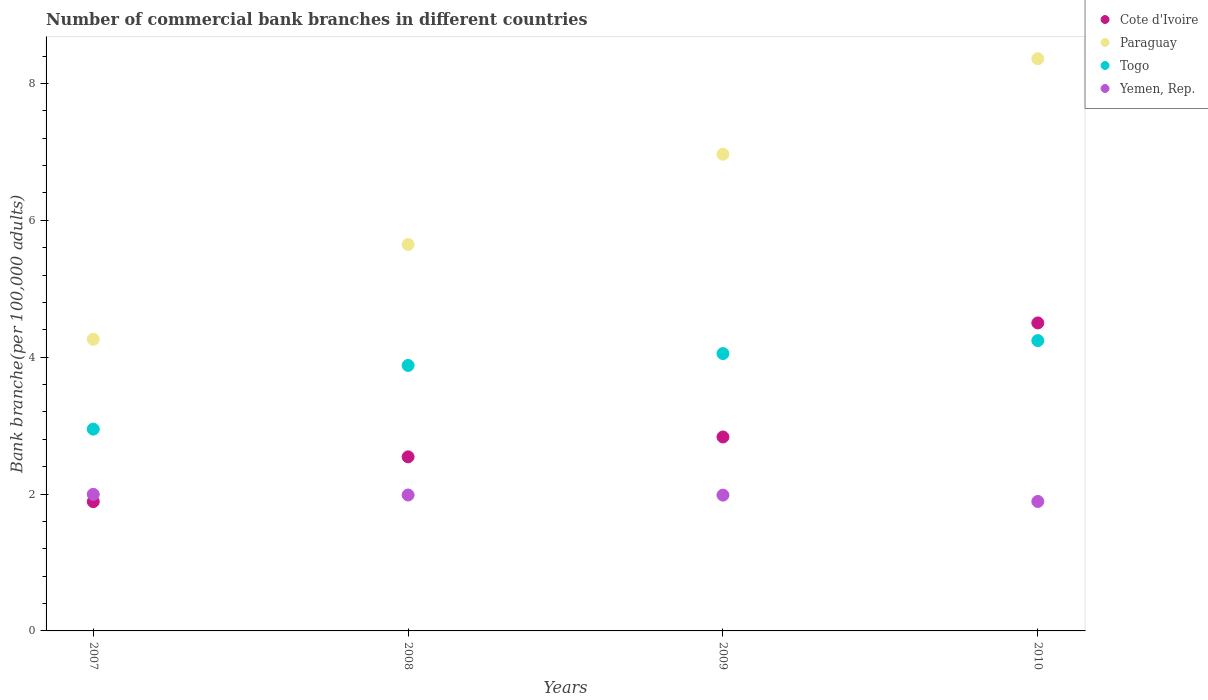Is the number of dotlines equal to the number of legend labels?
Make the answer very short. Yes. What is the number of commercial bank branches in Yemen, Rep. in 2008?
Keep it short and to the point. 1.99. Across all years, what is the maximum number of commercial bank branches in Cote d'Ivoire?
Your response must be concise. 4.5. Across all years, what is the minimum number of commercial bank branches in Cote d'Ivoire?
Provide a short and direct response. 1.89. In which year was the number of commercial bank branches in Cote d'Ivoire maximum?
Provide a succinct answer. 2010. In which year was the number of commercial bank branches in Togo minimum?
Make the answer very short. 2007. What is the total number of commercial bank branches in Paraguay in the graph?
Ensure brevity in your answer.  25.24. What is the difference between the number of commercial bank branches in Cote d'Ivoire in 2008 and that in 2010?
Give a very brief answer. -1.96. What is the difference between the number of commercial bank branches in Togo in 2008 and the number of commercial bank branches in Paraguay in 2010?
Make the answer very short. -4.48. What is the average number of commercial bank branches in Togo per year?
Provide a succinct answer. 3.78. In the year 2010, what is the difference between the number of commercial bank branches in Paraguay and number of commercial bank branches in Cote d'Ivoire?
Provide a short and direct response. 3.86. In how many years, is the number of commercial bank branches in Yemen, Rep. greater than 2?
Your answer should be very brief. 0. What is the ratio of the number of commercial bank branches in Togo in 2007 to that in 2008?
Make the answer very short. 0.76. Is the number of commercial bank branches in Cote d'Ivoire in 2009 less than that in 2010?
Provide a short and direct response. Yes. Is the difference between the number of commercial bank branches in Paraguay in 2008 and 2010 greater than the difference between the number of commercial bank branches in Cote d'Ivoire in 2008 and 2010?
Ensure brevity in your answer.  No. What is the difference between the highest and the second highest number of commercial bank branches in Togo?
Your answer should be compact. 0.19. What is the difference between the highest and the lowest number of commercial bank branches in Cote d'Ivoire?
Offer a very short reply. 2.61. In how many years, is the number of commercial bank branches in Cote d'Ivoire greater than the average number of commercial bank branches in Cote d'Ivoire taken over all years?
Keep it short and to the point. 1. Is the sum of the number of commercial bank branches in Togo in 2007 and 2010 greater than the maximum number of commercial bank branches in Paraguay across all years?
Provide a short and direct response. No. Is it the case that in every year, the sum of the number of commercial bank branches in Cote d'Ivoire and number of commercial bank branches in Yemen, Rep.  is greater than the sum of number of commercial bank branches in Paraguay and number of commercial bank branches in Togo?
Offer a terse response. No. Is the number of commercial bank branches in Paraguay strictly less than the number of commercial bank branches in Cote d'Ivoire over the years?
Your answer should be compact. No. How many dotlines are there?
Keep it short and to the point. 4. How many years are there in the graph?
Provide a succinct answer. 4. What is the difference between two consecutive major ticks on the Y-axis?
Your response must be concise. 2. Does the graph contain any zero values?
Make the answer very short. No. Where does the legend appear in the graph?
Offer a terse response. Top right. How many legend labels are there?
Offer a very short reply. 4. What is the title of the graph?
Offer a very short reply. Number of commercial bank branches in different countries. Does "Latin America(developing only)" appear as one of the legend labels in the graph?
Keep it short and to the point. No. What is the label or title of the X-axis?
Give a very brief answer. Years. What is the label or title of the Y-axis?
Your answer should be very brief. Bank branche(per 100,0 adults). What is the Bank branche(per 100,000 adults) of Cote d'Ivoire in 2007?
Offer a terse response. 1.89. What is the Bank branche(per 100,000 adults) of Paraguay in 2007?
Provide a succinct answer. 4.26. What is the Bank branche(per 100,000 adults) of Togo in 2007?
Your answer should be compact. 2.95. What is the Bank branche(per 100,000 adults) in Yemen, Rep. in 2007?
Provide a succinct answer. 2. What is the Bank branche(per 100,000 adults) of Cote d'Ivoire in 2008?
Offer a terse response. 2.54. What is the Bank branche(per 100,000 adults) in Paraguay in 2008?
Provide a short and direct response. 5.65. What is the Bank branche(per 100,000 adults) in Togo in 2008?
Your response must be concise. 3.88. What is the Bank branche(per 100,000 adults) in Yemen, Rep. in 2008?
Your answer should be compact. 1.99. What is the Bank branche(per 100,000 adults) in Cote d'Ivoire in 2009?
Give a very brief answer. 2.83. What is the Bank branche(per 100,000 adults) of Paraguay in 2009?
Your answer should be compact. 6.97. What is the Bank branche(per 100,000 adults) in Togo in 2009?
Give a very brief answer. 4.05. What is the Bank branche(per 100,000 adults) of Yemen, Rep. in 2009?
Your answer should be compact. 1.98. What is the Bank branche(per 100,000 adults) in Cote d'Ivoire in 2010?
Provide a short and direct response. 4.5. What is the Bank branche(per 100,000 adults) of Paraguay in 2010?
Provide a short and direct response. 8.36. What is the Bank branche(per 100,000 adults) of Togo in 2010?
Offer a very short reply. 4.24. What is the Bank branche(per 100,000 adults) in Yemen, Rep. in 2010?
Give a very brief answer. 1.89. Across all years, what is the maximum Bank branche(per 100,000 adults) of Cote d'Ivoire?
Your answer should be very brief. 4.5. Across all years, what is the maximum Bank branche(per 100,000 adults) in Paraguay?
Your answer should be compact. 8.36. Across all years, what is the maximum Bank branche(per 100,000 adults) of Togo?
Offer a very short reply. 4.24. Across all years, what is the maximum Bank branche(per 100,000 adults) in Yemen, Rep.?
Offer a terse response. 2. Across all years, what is the minimum Bank branche(per 100,000 adults) in Cote d'Ivoire?
Your response must be concise. 1.89. Across all years, what is the minimum Bank branche(per 100,000 adults) in Paraguay?
Give a very brief answer. 4.26. Across all years, what is the minimum Bank branche(per 100,000 adults) in Togo?
Provide a short and direct response. 2.95. Across all years, what is the minimum Bank branche(per 100,000 adults) in Yemen, Rep.?
Give a very brief answer. 1.89. What is the total Bank branche(per 100,000 adults) of Cote d'Ivoire in the graph?
Give a very brief answer. 11.77. What is the total Bank branche(per 100,000 adults) of Paraguay in the graph?
Your response must be concise. 25.24. What is the total Bank branche(per 100,000 adults) in Togo in the graph?
Offer a very short reply. 15.13. What is the total Bank branche(per 100,000 adults) in Yemen, Rep. in the graph?
Give a very brief answer. 7.86. What is the difference between the Bank branche(per 100,000 adults) of Cote d'Ivoire in 2007 and that in 2008?
Keep it short and to the point. -0.65. What is the difference between the Bank branche(per 100,000 adults) in Paraguay in 2007 and that in 2008?
Provide a short and direct response. -1.39. What is the difference between the Bank branche(per 100,000 adults) in Togo in 2007 and that in 2008?
Offer a very short reply. -0.93. What is the difference between the Bank branche(per 100,000 adults) in Yemen, Rep. in 2007 and that in 2008?
Your answer should be compact. 0.01. What is the difference between the Bank branche(per 100,000 adults) in Cote d'Ivoire in 2007 and that in 2009?
Your answer should be very brief. -0.94. What is the difference between the Bank branche(per 100,000 adults) of Paraguay in 2007 and that in 2009?
Keep it short and to the point. -2.7. What is the difference between the Bank branche(per 100,000 adults) in Togo in 2007 and that in 2009?
Provide a succinct answer. -1.1. What is the difference between the Bank branche(per 100,000 adults) of Yemen, Rep. in 2007 and that in 2009?
Provide a succinct answer. 0.01. What is the difference between the Bank branche(per 100,000 adults) in Cote d'Ivoire in 2007 and that in 2010?
Offer a very short reply. -2.61. What is the difference between the Bank branche(per 100,000 adults) of Paraguay in 2007 and that in 2010?
Make the answer very short. -4.1. What is the difference between the Bank branche(per 100,000 adults) of Togo in 2007 and that in 2010?
Keep it short and to the point. -1.29. What is the difference between the Bank branche(per 100,000 adults) of Yemen, Rep. in 2007 and that in 2010?
Your answer should be very brief. 0.1. What is the difference between the Bank branche(per 100,000 adults) in Cote d'Ivoire in 2008 and that in 2009?
Your answer should be very brief. -0.29. What is the difference between the Bank branche(per 100,000 adults) of Paraguay in 2008 and that in 2009?
Your answer should be very brief. -1.32. What is the difference between the Bank branche(per 100,000 adults) in Togo in 2008 and that in 2009?
Provide a short and direct response. -0.17. What is the difference between the Bank branche(per 100,000 adults) in Yemen, Rep. in 2008 and that in 2009?
Give a very brief answer. 0. What is the difference between the Bank branche(per 100,000 adults) in Cote d'Ivoire in 2008 and that in 2010?
Your answer should be compact. -1.96. What is the difference between the Bank branche(per 100,000 adults) in Paraguay in 2008 and that in 2010?
Your answer should be very brief. -2.71. What is the difference between the Bank branche(per 100,000 adults) of Togo in 2008 and that in 2010?
Offer a very short reply. -0.36. What is the difference between the Bank branche(per 100,000 adults) in Yemen, Rep. in 2008 and that in 2010?
Give a very brief answer. 0.09. What is the difference between the Bank branche(per 100,000 adults) of Cote d'Ivoire in 2009 and that in 2010?
Offer a very short reply. -1.67. What is the difference between the Bank branche(per 100,000 adults) of Paraguay in 2009 and that in 2010?
Provide a short and direct response. -1.4. What is the difference between the Bank branche(per 100,000 adults) of Togo in 2009 and that in 2010?
Your answer should be compact. -0.19. What is the difference between the Bank branche(per 100,000 adults) in Yemen, Rep. in 2009 and that in 2010?
Your answer should be very brief. 0.09. What is the difference between the Bank branche(per 100,000 adults) of Cote d'Ivoire in 2007 and the Bank branche(per 100,000 adults) of Paraguay in 2008?
Offer a terse response. -3.76. What is the difference between the Bank branche(per 100,000 adults) of Cote d'Ivoire in 2007 and the Bank branche(per 100,000 adults) of Togo in 2008?
Ensure brevity in your answer.  -1.99. What is the difference between the Bank branche(per 100,000 adults) of Cote d'Ivoire in 2007 and the Bank branche(per 100,000 adults) of Yemen, Rep. in 2008?
Offer a terse response. -0.1. What is the difference between the Bank branche(per 100,000 adults) of Paraguay in 2007 and the Bank branche(per 100,000 adults) of Togo in 2008?
Provide a short and direct response. 0.38. What is the difference between the Bank branche(per 100,000 adults) of Paraguay in 2007 and the Bank branche(per 100,000 adults) of Yemen, Rep. in 2008?
Provide a short and direct response. 2.28. What is the difference between the Bank branche(per 100,000 adults) in Togo in 2007 and the Bank branche(per 100,000 adults) in Yemen, Rep. in 2008?
Your answer should be compact. 0.96. What is the difference between the Bank branche(per 100,000 adults) of Cote d'Ivoire in 2007 and the Bank branche(per 100,000 adults) of Paraguay in 2009?
Your response must be concise. -5.08. What is the difference between the Bank branche(per 100,000 adults) of Cote d'Ivoire in 2007 and the Bank branche(per 100,000 adults) of Togo in 2009?
Provide a short and direct response. -2.16. What is the difference between the Bank branche(per 100,000 adults) in Cote d'Ivoire in 2007 and the Bank branche(per 100,000 adults) in Yemen, Rep. in 2009?
Your answer should be compact. -0.1. What is the difference between the Bank branche(per 100,000 adults) in Paraguay in 2007 and the Bank branche(per 100,000 adults) in Togo in 2009?
Your answer should be compact. 0.21. What is the difference between the Bank branche(per 100,000 adults) of Paraguay in 2007 and the Bank branche(per 100,000 adults) of Yemen, Rep. in 2009?
Offer a very short reply. 2.28. What is the difference between the Bank branche(per 100,000 adults) of Togo in 2007 and the Bank branche(per 100,000 adults) of Yemen, Rep. in 2009?
Your answer should be compact. 0.96. What is the difference between the Bank branche(per 100,000 adults) of Cote d'Ivoire in 2007 and the Bank branche(per 100,000 adults) of Paraguay in 2010?
Give a very brief answer. -6.47. What is the difference between the Bank branche(per 100,000 adults) of Cote d'Ivoire in 2007 and the Bank branche(per 100,000 adults) of Togo in 2010?
Offer a very short reply. -2.35. What is the difference between the Bank branche(per 100,000 adults) of Cote d'Ivoire in 2007 and the Bank branche(per 100,000 adults) of Yemen, Rep. in 2010?
Offer a terse response. -0. What is the difference between the Bank branche(per 100,000 adults) in Paraguay in 2007 and the Bank branche(per 100,000 adults) in Togo in 2010?
Provide a succinct answer. 0.02. What is the difference between the Bank branche(per 100,000 adults) of Paraguay in 2007 and the Bank branche(per 100,000 adults) of Yemen, Rep. in 2010?
Provide a succinct answer. 2.37. What is the difference between the Bank branche(per 100,000 adults) in Togo in 2007 and the Bank branche(per 100,000 adults) in Yemen, Rep. in 2010?
Offer a very short reply. 1.06. What is the difference between the Bank branche(per 100,000 adults) of Cote d'Ivoire in 2008 and the Bank branche(per 100,000 adults) of Paraguay in 2009?
Provide a short and direct response. -4.42. What is the difference between the Bank branche(per 100,000 adults) of Cote d'Ivoire in 2008 and the Bank branche(per 100,000 adults) of Togo in 2009?
Make the answer very short. -1.51. What is the difference between the Bank branche(per 100,000 adults) in Cote d'Ivoire in 2008 and the Bank branche(per 100,000 adults) in Yemen, Rep. in 2009?
Offer a terse response. 0.56. What is the difference between the Bank branche(per 100,000 adults) in Paraguay in 2008 and the Bank branche(per 100,000 adults) in Togo in 2009?
Provide a succinct answer. 1.59. What is the difference between the Bank branche(per 100,000 adults) of Paraguay in 2008 and the Bank branche(per 100,000 adults) of Yemen, Rep. in 2009?
Your answer should be compact. 3.66. What is the difference between the Bank branche(per 100,000 adults) in Togo in 2008 and the Bank branche(per 100,000 adults) in Yemen, Rep. in 2009?
Your answer should be compact. 1.9. What is the difference between the Bank branche(per 100,000 adults) in Cote d'Ivoire in 2008 and the Bank branche(per 100,000 adults) in Paraguay in 2010?
Your answer should be compact. -5.82. What is the difference between the Bank branche(per 100,000 adults) of Cote d'Ivoire in 2008 and the Bank branche(per 100,000 adults) of Togo in 2010?
Ensure brevity in your answer.  -1.7. What is the difference between the Bank branche(per 100,000 adults) in Cote d'Ivoire in 2008 and the Bank branche(per 100,000 adults) in Yemen, Rep. in 2010?
Your answer should be very brief. 0.65. What is the difference between the Bank branche(per 100,000 adults) of Paraguay in 2008 and the Bank branche(per 100,000 adults) of Togo in 2010?
Keep it short and to the point. 1.4. What is the difference between the Bank branche(per 100,000 adults) in Paraguay in 2008 and the Bank branche(per 100,000 adults) in Yemen, Rep. in 2010?
Ensure brevity in your answer.  3.76. What is the difference between the Bank branche(per 100,000 adults) of Togo in 2008 and the Bank branche(per 100,000 adults) of Yemen, Rep. in 2010?
Provide a short and direct response. 1.99. What is the difference between the Bank branche(per 100,000 adults) of Cote d'Ivoire in 2009 and the Bank branche(per 100,000 adults) of Paraguay in 2010?
Your answer should be compact. -5.53. What is the difference between the Bank branche(per 100,000 adults) in Cote d'Ivoire in 2009 and the Bank branche(per 100,000 adults) in Togo in 2010?
Your response must be concise. -1.41. What is the difference between the Bank branche(per 100,000 adults) in Cote d'Ivoire in 2009 and the Bank branche(per 100,000 adults) in Yemen, Rep. in 2010?
Your response must be concise. 0.94. What is the difference between the Bank branche(per 100,000 adults) in Paraguay in 2009 and the Bank branche(per 100,000 adults) in Togo in 2010?
Provide a short and direct response. 2.72. What is the difference between the Bank branche(per 100,000 adults) in Paraguay in 2009 and the Bank branche(per 100,000 adults) in Yemen, Rep. in 2010?
Make the answer very short. 5.07. What is the difference between the Bank branche(per 100,000 adults) of Togo in 2009 and the Bank branche(per 100,000 adults) of Yemen, Rep. in 2010?
Make the answer very short. 2.16. What is the average Bank branche(per 100,000 adults) of Cote d'Ivoire per year?
Your answer should be very brief. 2.94. What is the average Bank branche(per 100,000 adults) in Paraguay per year?
Make the answer very short. 6.31. What is the average Bank branche(per 100,000 adults) of Togo per year?
Make the answer very short. 3.78. What is the average Bank branche(per 100,000 adults) in Yemen, Rep. per year?
Give a very brief answer. 1.96. In the year 2007, what is the difference between the Bank branche(per 100,000 adults) of Cote d'Ivoire and Bank branche(per 100,000 adults) of Paraguay?
Make the answer very short. -2.37. In the year 2007, what is the difference between the Bank branche(per 100,000 adults) in Cote d'Ivoire and Bank branche(per 100,000 adults) in Togo?
Give a very brief answer. -1.06. In the year 2007, what is the difference between the Bank branche(per 100,000 adults) in Cote d'Ivoire and Bank branche(per 100,000 adults) in Yemen, Rep.?
Your answer should be compact. -0.11. In the year 2007, what is the difference between the Bank branche(per 100,000 adults) in Paraguay and Bank branche(per 100,000 adults) in Togo?
Your response must be concise. 1.31. In the year 2007, what is the difference between the Bank branche(per 100,000 adults) in Paraguay and Bank branche(per 100,000 adults) in Yemen, Rep.?
Make the answer very short. 2.27. In the year 2007, what is the difference between the Bank branche(per 100,000 adults) in Togo and Bank branche(per 100,000 adults) in Yemen, Rep.?
Provide a short and direct response. 0.95. In the year 2008, what is the difference between the Bank branche(per 100,000 adults) in Cote d'Ivoire and Bank branche(per 100,000 adults) in Paraguay?
Give a very brief answer. -3.1. In the year 2008, what is the difference between the Bank branche(per 100,000 adults) in Cote d'Ivoire and Bank branche(per 100,000 adults) in Togo?
Keep it short and to the point. -1.34. In the year 2008, what is the difference between the Bank branche(per 100,000 adults) in Cote d'Ivoire and Bank branche(per 100,000 adults) in Yemen, Rep.?
Provide a succinct answer. 0.56. In the year 2008, what is the difference between the Bank branche(per 100,000 adults) in Paraguay and Bank branche(per 100,000 adults) in Togo?
Your answer should be compact. 1.77. In the year 2008, what is the difference between the Bank branche(per 100,000 adults) of Paraguay and Bank branche(per 100,000 adults) of Yemen, Rep.?
Your response must be concise. 3.66. In the year 2008, what is the difference between the Bank branche(per 100,000 adults) in Togo and Bank branche(per 100,000 adults) in Yemen, Rep.?
Your answer should be very brief. 1.89. In the year 2009, what is the difference between the Bank branche(per 100,000 adults) in Cote d'Ivoire and Bank branche(per 100,000 adults) in Paraguay?
Your response must be concise. -4.13. In the year 2009, what is the difference between the Bank branche(per 100,000 adults) in Cote d'Ivoire and Bank branche(per 100,000 adults) in Togo?
Give a very brief answer. -1.22. In the year 2009, what is the difference between the Bank branche(per 100,000 adults) of Cote d'Ivoire and Bank branche(per 100,000 adults) of Yemen, Rep.?
Provide a short and direct response. 0.85. In the year 2009, what is the difference between the Bank branche(per 100,000 adults) of Paraguay and Bank branche(per 100,000 adults) of Togo?
Ensure brevity in your answer.  2.91. In the year 2009, what is the difference between the Bank branche(per 100,000 adults) in Paraguay and Bank branche(per 100,000 adults) in Yemen, Rep.?
Your answer should be compact. 4.98. In the year 2009, what is the difference between the Bank branche(per 100,000 adults) in Togo and Bank branche(per 100,000 adults) in Yemen, Rep.?
Keep it short and to the point. 2.07. In the year 2010, what is the difference between the Bank branche(per 100,000 adults) of Cote d'Ivoire and Bank branche(per 100,000 adults) of Paraguay?
Your answer should be compact. -3.86. In the year 2010, what is the difference between the Bank branche(per 100,000 adults) in Cote d'Ivoire and Bank branche(per 100,000 adults) in Togo?
Make the answer very short. 0.26. In the year 2010, what is the difference between the Bank branche(per 100,000 adults) of Cote d'Ivoire and Bank branche(per 100,000 adults) of Yemen, Rep.?
Make the answer very short. 2.61. In the year 2010, what is the difference between the Bank branche(per 100,000 adults) of Paraguay and Bank branche(per 100,000 adults) of Togo?
Your response must be concise. 4.12. In the year 2010, what is the difference between the Bank branche(per 100,000 adults) in Paraguay and Bank branche(per 100,000 adults) in Yemen, Rep.?
Your answer should be very brief. 6.47. In the year 2010, what is the difference between the Bank branche(per 100,000 adults) in Togo and Bank branche(per 100,000 adults) in Yemen, Rep.?
Provide a short and direct response. 2.35. What is the ratio of the Bank branche(per 100,000 adults) of Cote d'Ivoire in 2007 to that in 2008?
Your answer should be compact. 0.74. What is the ratio of the Bank branche(per 100,000 adults) of Paraguay in 2007 to that in 2008?
Offer a terse response. 0.75. What is the ratio of the Bank branche(per 100,000 adults) of Togo in 2007 to that in 2008?
Provide a succinct answer. 0.76. What is the ratio of the Bank branche(per 100,000 adults) of Cote d'Ivoire in 2007 to that in 2009?
Provide a succinct answer. 0.67. What is the ratio of the Bank branche(per 100,000 adults) in Paraguay in 2007 to that in 2009?
Your response must be concise. 0.61. What is the ratio of the Bank branche(per 100,000 adults) in Togo in 2007 to that in 2009?
Your response must be concise. 0.73. What is the ratio of the Bank branche(per 100,000 adults) in Yemen, Rep. in 2007 to that in 2009?
Your answer should be very brief. 1.01. What is the ratio of the Bank branche(per 100,000 adults) of Cote d'Ivoire in 2007 to that in 2010?
Offer a very short reply. 0.42. What is the ratio of the Bank branche(per 100,000 adults) of Paraguay in 2007 to that in 2010?
Ensure brevity in your answer.  0.51. What is the ratio of the Bank branche(per 100,000 adults) in Togo in 2007 to that in 2010?
Your answer should be compact. 0.7. What is the ratio of the Bank branche(per 100,000 adults) in Yemen, Rep. in 2007 to that in 2010?
Provide a succinct answer. 1.05. What is the ratio of the Bank branche(per 100,000 adults) in Cote d'Ivoire in 2008 to that in 2009?
Make the answer very short. 0.9. What is the ratio of the Bank branche(per 100,000 adults) in Paraguay in 2008 to that in 2009?
Offer a terse response. 0.81. What is the ratio of the Bank branche(per 100,000 adults) in Togo in 2008 to that in 2009?
Give a very brief answer. 0.96. What is the ratio of the Bank branche(per 100,000 adults) of Yemen, Rep. in 2008 to that in 2009?
Provide a succinct answer. 1. What is the ratio of the Bank branche(per 100,000 adults) in Cote d'Ivoire in 2008 to that in 2010?
Keep it short and to the point. 0.57. What is the ratio of the Bank branche(per 100,000 adults) in Paraguay in 2008 to that in 2010?
Your response must be concise. 0.68. What is the ratio of the Bank branche(per 100,000 adults) of Togo in 2008 to that in 2010?
Your answer should be compact. 0.91. What is the ratio of the Bank branche(per 100,000 adults) of Yemen, Rep. in 2008 to that in 2010?
Your answer should be very brief. 1.05. What is the ratio of the Bank branche(per 100,000 adults) of Cote d'Ivoire in 2009 to that in 2010?
Offer a terse response. 0.63. What is the ratio of the Bank branche(per 100,000 adults) of Paraguay in 2009 to that in 2010?
Make the answer very short. 0.83. What is the ratio of the Bank branche(per 100,000 adults) of Togo in 2009 to that in 2010?
Your answer should be compact. 0.96. What is the ratio of the Bank branche(per 100,000 adults) of Yemen, Rep. in 2009 to that in 2010?
Provide a succinct answer. 1.05. What is the difference between the highest and the second highest Bank branche(per 100,000 adults) in Cote d'Ivoire?
Offer a very short reply. 1.67. What is the difference between the highest and the second highest Bank branche(per 100,000 adults) in Paraguay?
Keep it short and to the point. 1.4. What is the difference between the highest and the second highest Bank branche(per 100,000 adults) in Togo?
Make the answer very short. 0.19. What is the difference between the highest and the second highest Bank branche(per 100,000 adults) of Yemen, Rep.?
Provide a succinct answer. 0.01. What is the difference between the highest and the lowest Bank branche(per 100,000 adults) in Cote d'Ivoire?
Make the answer very short. 2.61. What is the difference between the highest and the lowest Bank branche(per 100,000 adults) of Paraguay?
Your answer should be very brief. 4.1. What is the difference between the highest and the lowest Bank branche(per 100,000 adults) of Togo?
Your response must be concise. 1.29. What is the difference between the highest and the lowest Bank branche(per 100,000 adults) in Yemen, Rep.?
Ensure brevity in your answer.  0.1. 